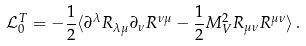Convert formula to latex. <formula><loc_0><loc_0><loc_500><loc_500>\mathcal { L } ^ { T } _ { 0 } = - \frac { 1 } { 2 } \langle \partial ^ { \lambda } R _ { \lambda \mu } \partial _ { \nu } R ^ { \nu \mu } - \frac { 1 } { 2 } M _ { V } ^ { 2 } R _ { \mu \nu } R ^ { \mu \nu } \rangle \, .</formula> 